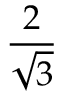<formula> <loc_0><loc_0><loc_500><loc_500>\frac { 2 } { \sqrt { 3 } }</formula> 